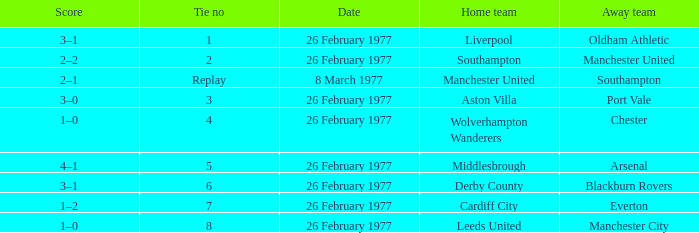Who was the domestic team that played against manchester united? Southampton. 